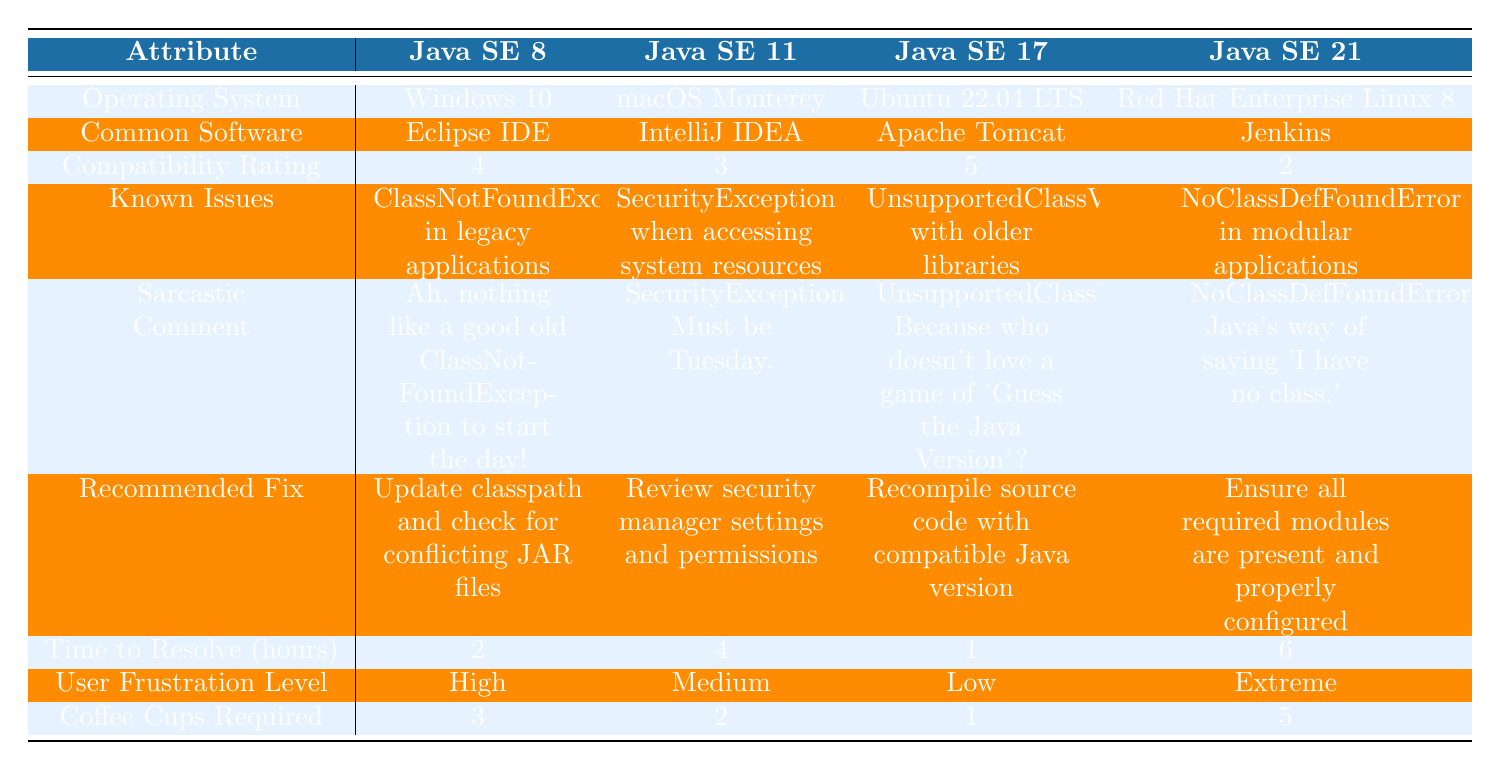What Java version has the highest compatibility rating? The compatibility ratings for each Java version are: Java SE 8 (4), Java SE 11 (3), Java SE 17 (5), and Java SE 21 (2). The highest rating is 5 for Java SE 17.
Answer: Java SE 17 What is the recommended fix for the issue with "NoClassDefFoundError"? The recommended fix corresponding to "NoClassDefFoundError" is "Ensure all required modules are present and properly configured."
Answer: Ensure all required modules are present and properly configured Which operating system has a high user frustration level? The user frustration levels are categorized as High, Medium, Low, and Extreme. The only high user frustration level is associated with Java SE 8 running on Windows 10.
Answer: Windows 10 What is the average time to resolve issues across all Java versions? Summing the time to resolve values gives: (2 + 4 + 1 + 6) = 13 hours. There are 4 Java versions. The average is 13/4 = 3.25 hours.
Answer: 3.25 hours Is there a Java version with a low compatibility rating that requires more than four hours to resolve? Java SE 21 has a compatibility rating of 2 (low) and a time to resolve of 6 hours, which meets the criteria for both low compatibility and high resolution time.
Answer: Yes Which Java version has the lowest coffee cups required for issues? The coffee cups required are: Java SE 8 (3), Java SE 11 (2), Java SE 17 (1), and Java SE 21 (5). The lowest is 1 for Java SE 17.
Answer: Java SE 17 For Java SE 11, what is the known issue and the sarcastic comment associated with it? The known issue for Java SE 11 is "SecurityException when accessing system resources" and the sarcastic comment is "SecurityException? Must be Tuesday."
Answer: SecurityException when accessing system resources; SecurityException? Must be Tuesday Which Java version has the shortest time to resolve issues? The times to resolve are: Java SE 8 (2 hours), Java SE 11 (4 hours), Java SE 17 (1 hour), and Java SE 21 (6 hours). The shortest is 1 hour for Java SE 17.
Answer: Java SE 17 What is the compatibility rating for the common software "Jenkins"? Jenkins is associated with Java SE 21, which has a compatibility rating of 2.
Answer: 2 Is there any software that has a compatibility rating of 5? Yes, Apache Tomcat is compatible with Java SE 17, which has a compatibility rating of 5.
Answer: Yes 